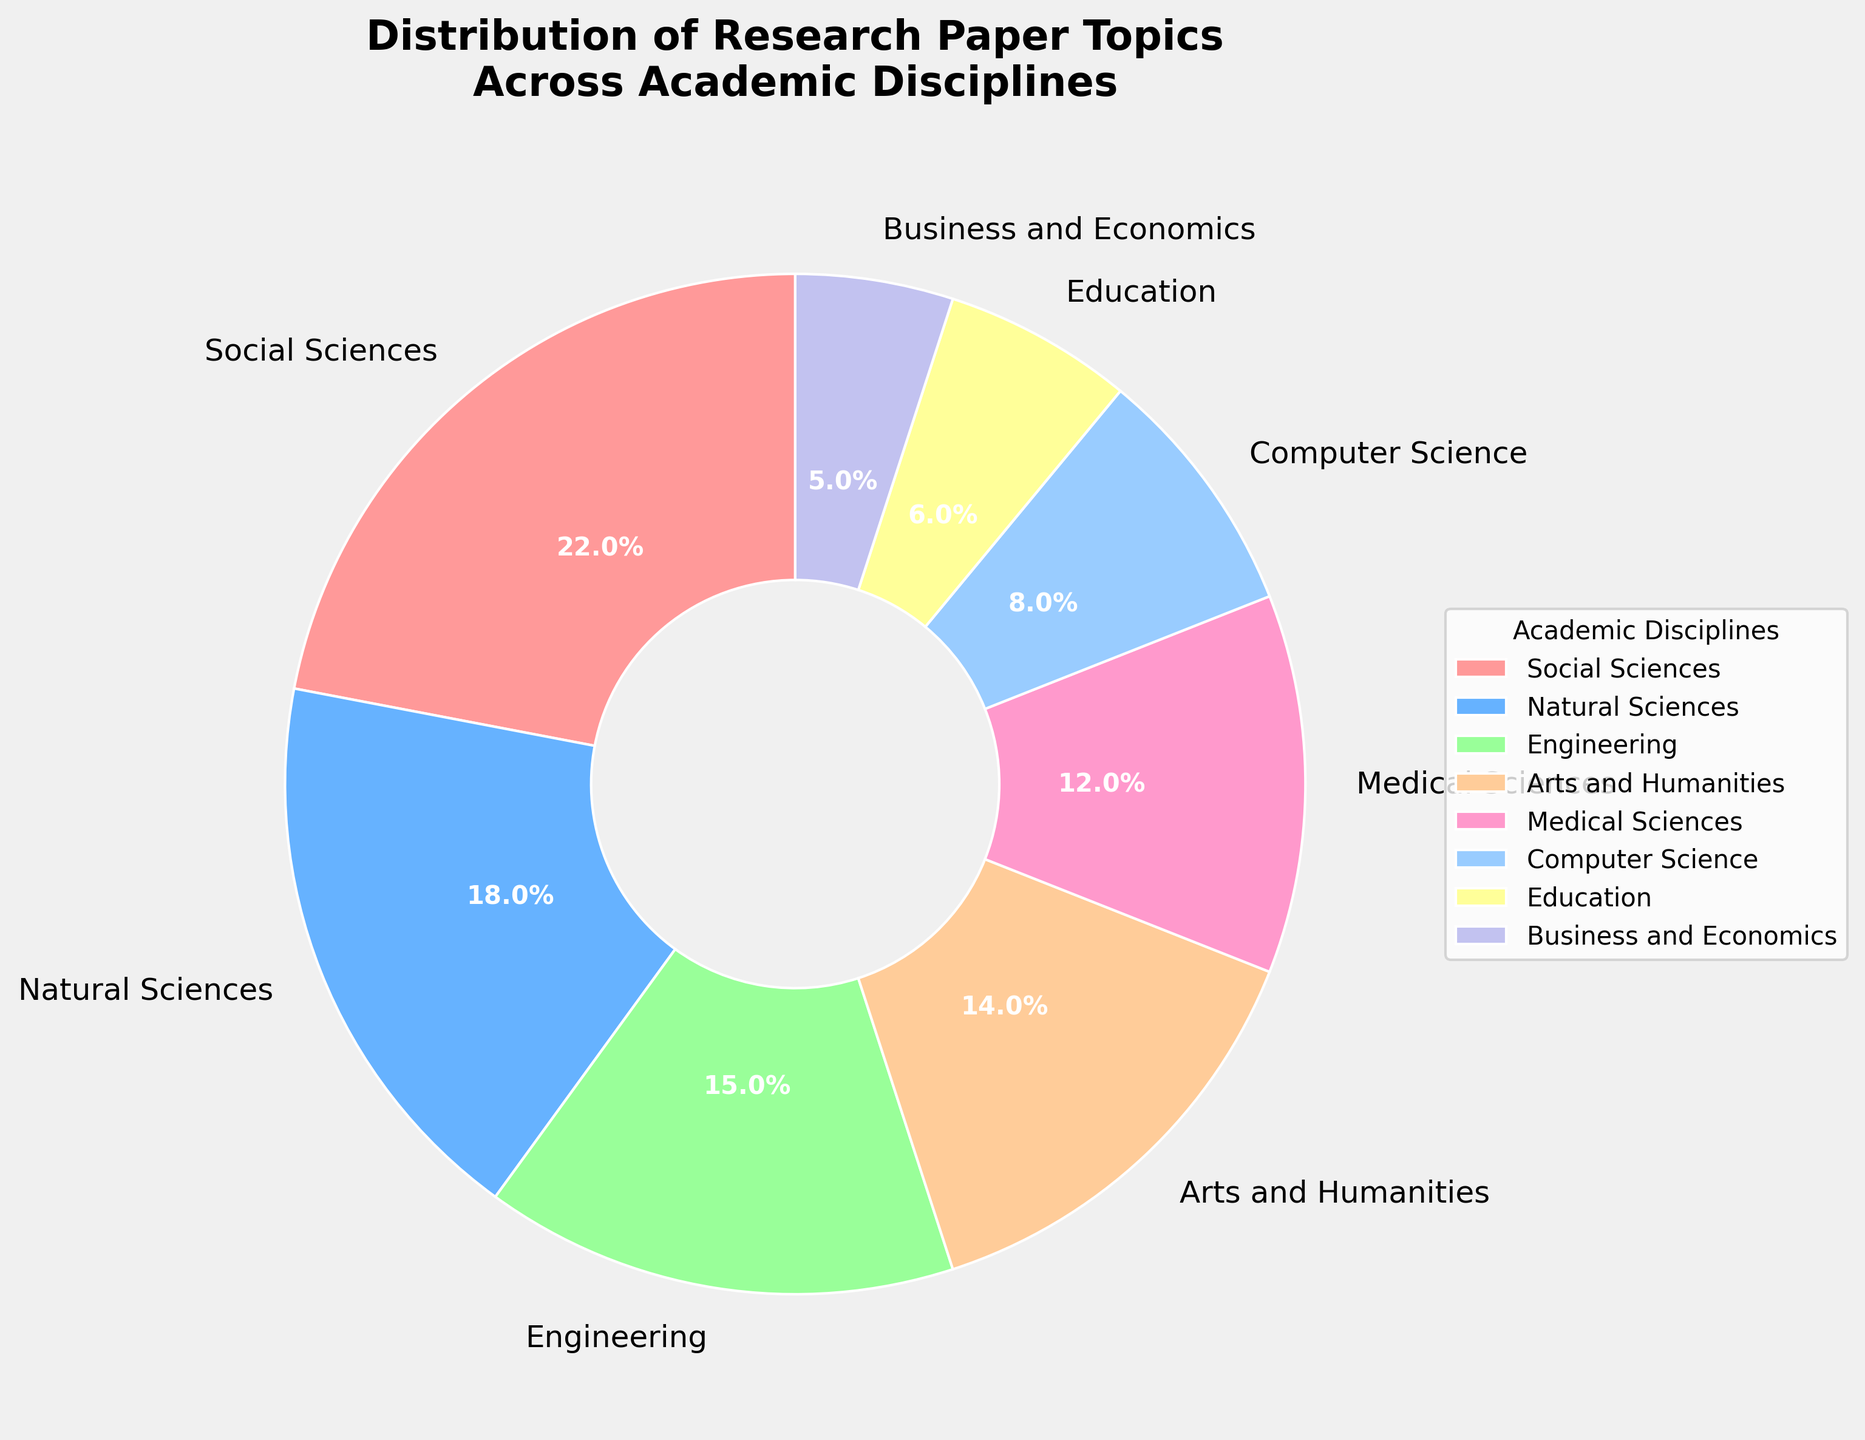What's the percentage distribution of topics between Social Sciences and Engineering? To find the total percentage for Social Sciences and Engineering together, sum their individual percentages: Social Sciences (22%) and Engineering (15%). Thus, 22 + 15 = 37.
Answer: 37% Which discipline has the smallest share in the pie chart? Looking at the pie chart, the smallest slice corresponds to Business and Economics with a percentage of 5%.
Answer: Business and Economics How does the size of the slice for Natural Sciences compare to that for Medical Sciences? The slice for Natural Sciences is larger at 18%, whereas Medical Sciences is at 12%. Natural Sciences, therefore, have a 6% larger share than Medical Sciences.
Answer: Natural Sciences have 6% more Which discipline occupies more than 20% of the distribution? Among the disciplines listed, only Social Sciences account for more than 20% of the distribution, specifically 22%.
Answer: Social Sciences Compare the sum percentage of Arts and Humanities, and Computer Science to Natural Sciences. Is it greater or smaller? The sum of percentages for Arts and Humanities (14%) and Computer Science (8%) is 22%. The percentage for Natural Sciences is 18%. Since 22% is greater than 18%, the combined share of Arts and Humanities and Computer Science is greater than that of Natural Sciences.
Answer: Greater What's the difference in percentage between the largest and the smallest slices in the chart? The largest slice is Social Sciences at 22%, and the smallest is Business and Economics at 5%. The difference is 22 - 5 = 17%.
Answer: 17% If you group Engineering, Computer Science, and Natural Sciences together, what percentage of the chart would they occupy? Add the percentages for Engineering (15%), Computer Science (8%), and Natural Sciences (18%) to get the total. Thus, 15 + 8 + 18 = 41%.
Answer: 41% What color represents the Medical Sciences on the pie chart? In the pie chart, the Medical Sciences slice is represented in a shade of pink.
Answer: Pink What's the combined percentage of the disciplines focused on technology and applied sciences (Engineering and Computer Science)? Sum the percentages for Engineering (15%) and Computer Science (8%). Thus, 15 + 8 = 23%.
Answer: 23% How many academic disciplines have a share that is below 10% in the pie chart? From the chart, the disciplines with shares below 10% are Computer Science (8%), Education (6%), and Business and Economics (5%). Therefore, there are three such disciplines.
Answer: 3 